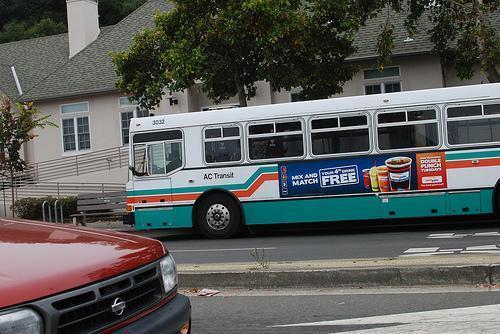How many vehicles are shown?
Give a very brief answer. 2. 